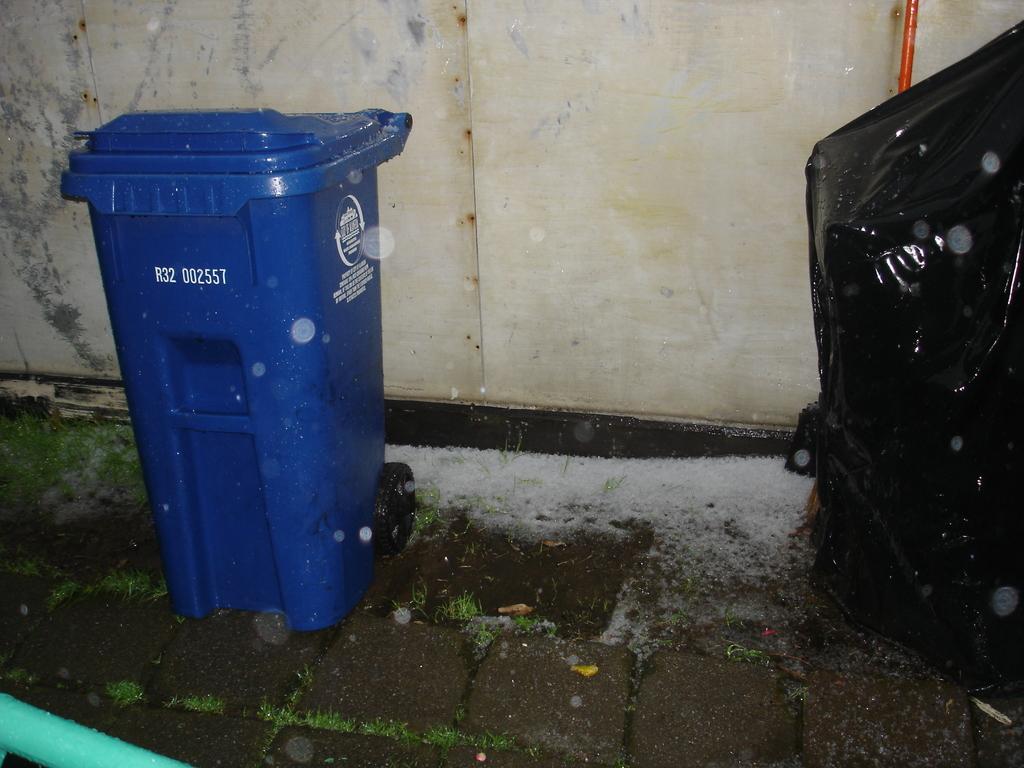What is the serial number of the trash can?
Ensure brevity in your answer.  R32 002557. 